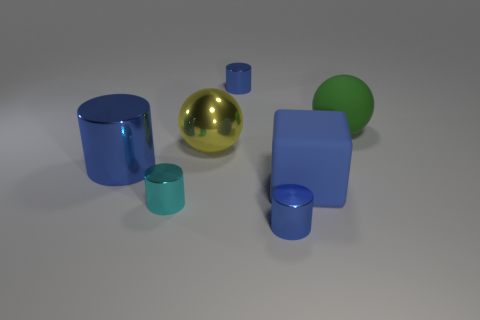Subtract all green spheres. How many blue cylinders are left? 3 Add 2 big brown cubes. How many objects exist? 9 Subtract all spheres. How many objects are left? 5 Add 6 small purple cylinders. How many small purple cylinders exist? 6 Subtract 0 gray spheres. How many objects are left? 7 Subtract all tiny cyan metal objects. Subtract all cyan metallic objects. How many objects are left? 5 Add 4 small blue objects. How many small blue objects are left? 6 